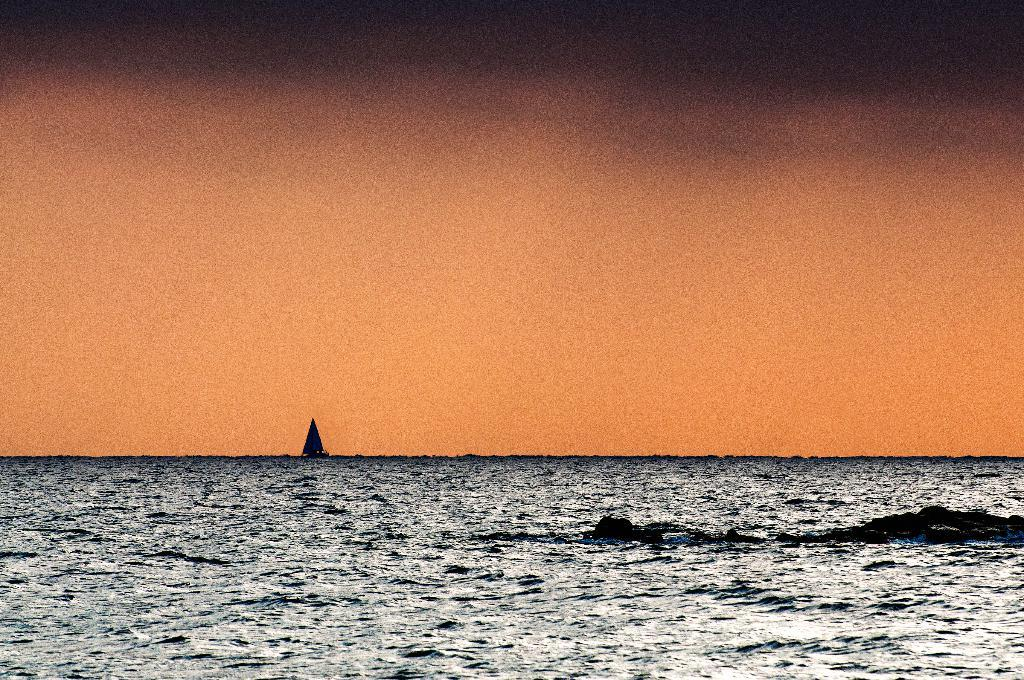What is the main subject of the image? There is a boat in the image. Where is the boat located? The boat is on the sea. What can be seen in the background of the image? The sky is visible in the background of the image. Can you see a hen in the boat in the image? There is no hen present in the image. Who is the friend of the person in the boat in the image? There is no person or friend mentioned in the image. 